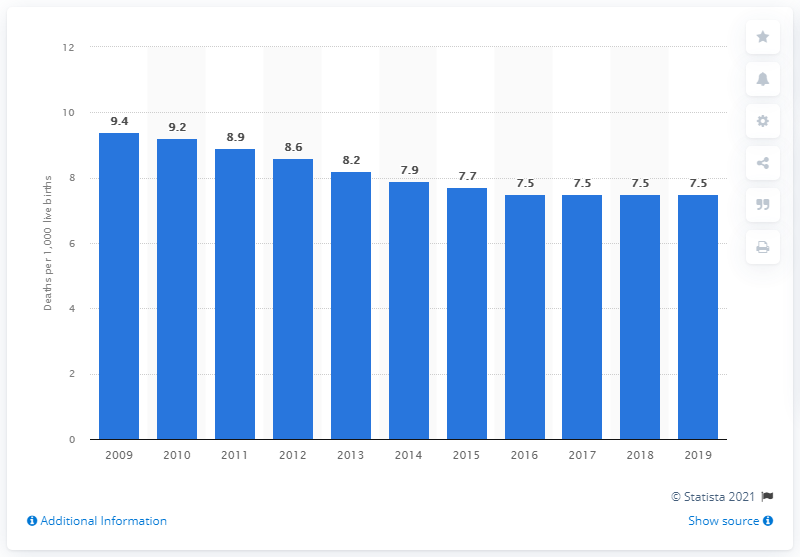Specify some key components in this picture. In 2019, the infant mortality rate in Costa Rica was 7.5 per 1,000 live births. 